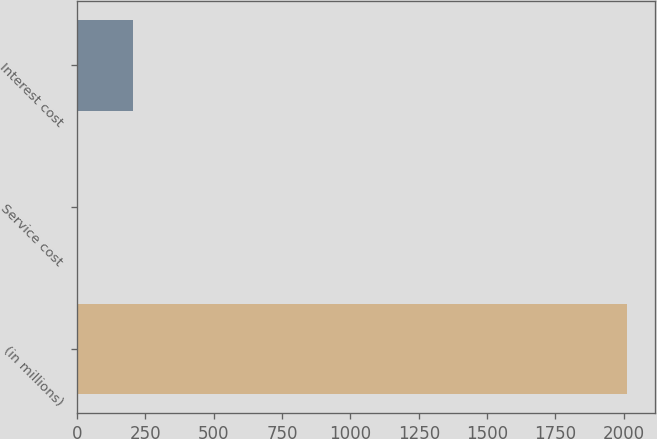Convert chart. <chart><loc_0><loc_0><loc_500><loc_500><bar_chart><fcel>(in millions)<fcel>Service cost<fcel>Interest cost<nl><fcel>2012<fcel>5<fcel>205.7<nl></chart> 